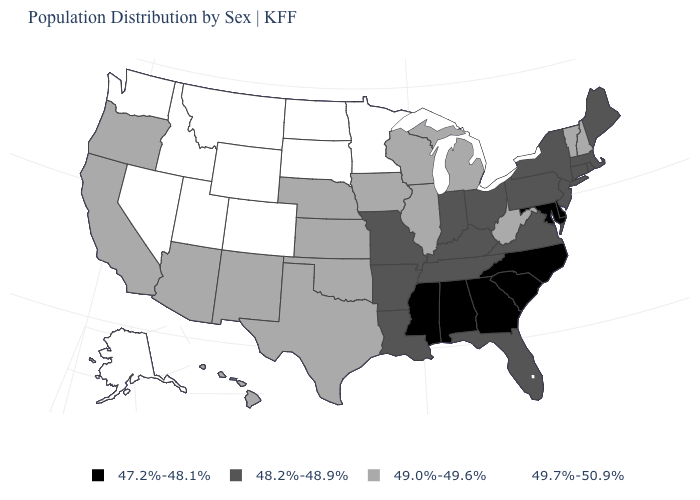What is the value of Connecticut?
Short answer required. 48.2%-48.9%. Name the states that have a value in the range 47.2%-48.1%?
Short answer required. Alabama, Delaware, Georgia, Maryland, Mississippi, North Carolina, South Carolina. What is the value of New Jersey?
Write a very short answer. 48.2%-48.9%. What is the highest value in the USA?
Short answer required. 49.7%-50.9%. What is the value of Arkansas?
Quick response, please. 48.2%-48.9%. Name the states that have a value in the range 49.7%-50.9%?
Answer briefly. Alaska, Colorado, Idaho, Minnesota, Montana, Nevada, North Dakota, South Dakota, Utah, Washington, Wyoming. Does Nebraska have the highest value in the USA?
Write a very short answer. No. Does Massachusetts have the same value as Louisiana?
Give a very brief answer. Yes. Name the states that have a value in the range 48.2%-48.9%?
Quick response, please. Arkansas, Connecticut, Florida, Indiana, Kentucky, Louisiana, Maine, Massachusetts, Missouri, New Jersey, New York, Ohio, Pennsylvania, Rhode Island, Tennessee, Virginia. What is the value of Arizona?
Answer briefly. 49.0%-49.6%. What is the value of Illinois?
Answer briefly. 49.0%-49.6%. Does Montana have a higher value than Washington?
Quick response, please. No. What is the value of South Carolina?
Give a very brief answer. 47.2%-48.1%. What is the value of Mississippi?
Answer briefly. 47.2%-48.1%. What is the value of Maine?
Write a very short answer. 48.2%-48.9%. 